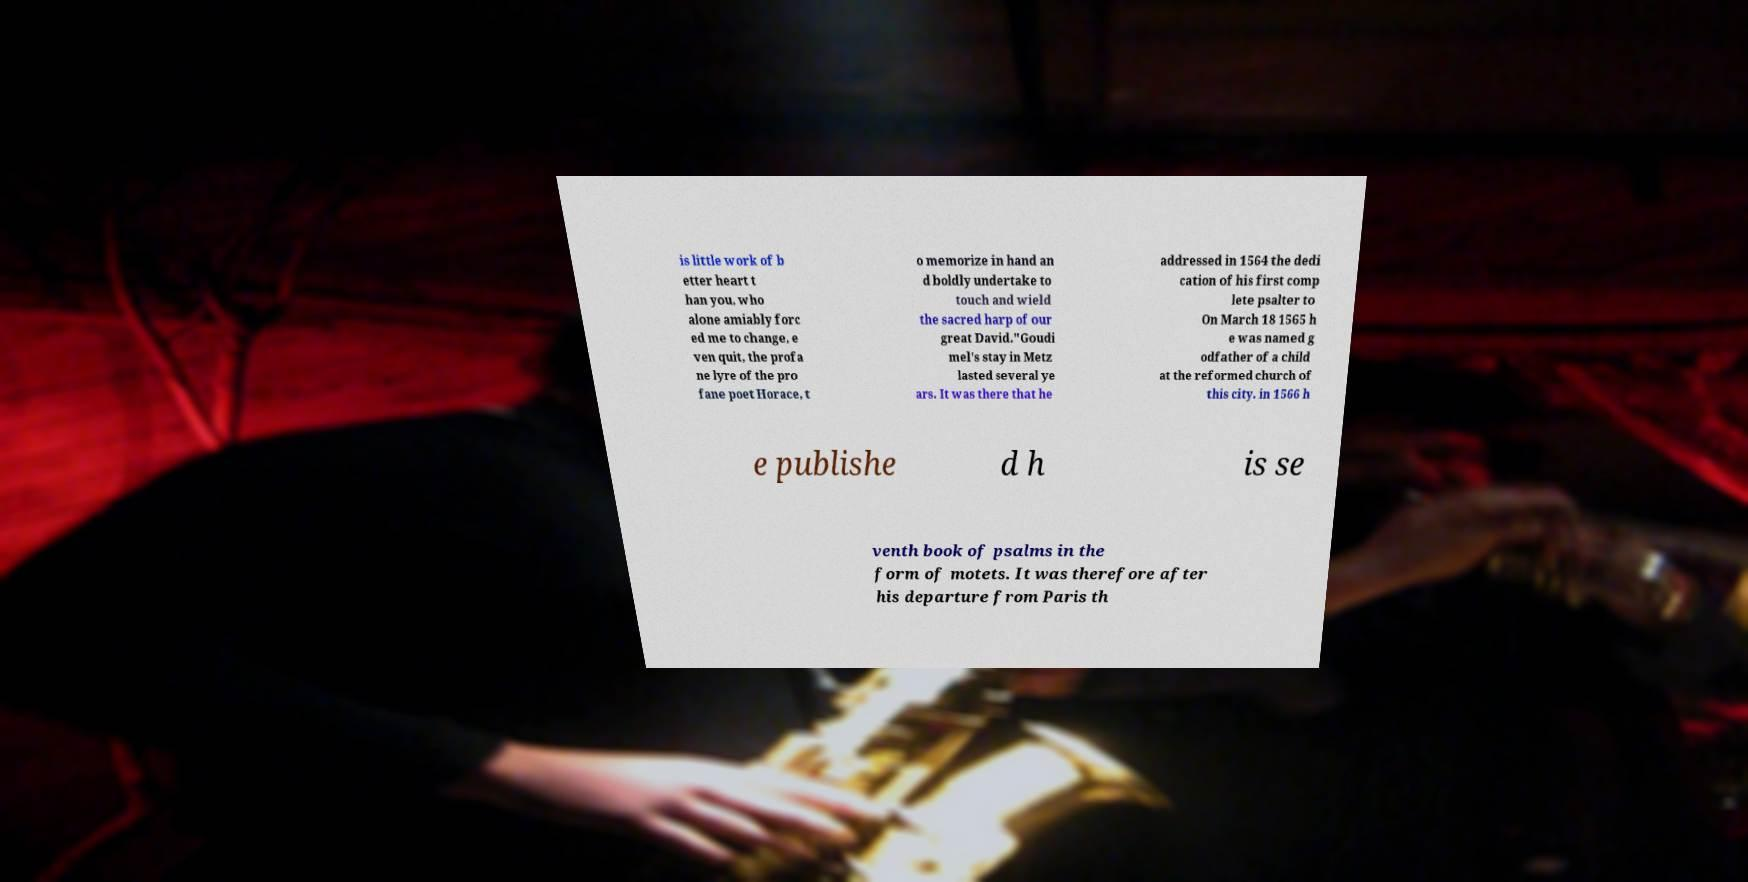Can you accurately transcribe the text from the provided image for me? is little work of b etter heart t han you, who alone amiably forc ed me to change, e ven quit, the profa ne lyre of the pro fane poet Horace, t o memorize in hand an d boldly undertake to touch and wield the sacred harp of our great David."Goudi mel's stay in Metz lasted several ye ars. It was there that he addressed in 1564 the dedi cation of his first comp lete psalter to On March 18 1565 h e was named g odfather of a child at the reformed church of this city. in 1566 h e publishe d h is se venth book of psalms in the form of motets. It was therefore after his departure from Paris th 